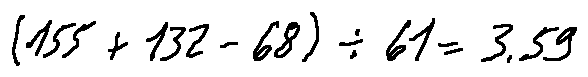Convert formula to latex. <formula><loc_0><loc_0><loc_500><loc_500>( 1 5 5 + 1 3 2 - 6 8 ) \div 6 1 = 3 . 5 9</formula> 